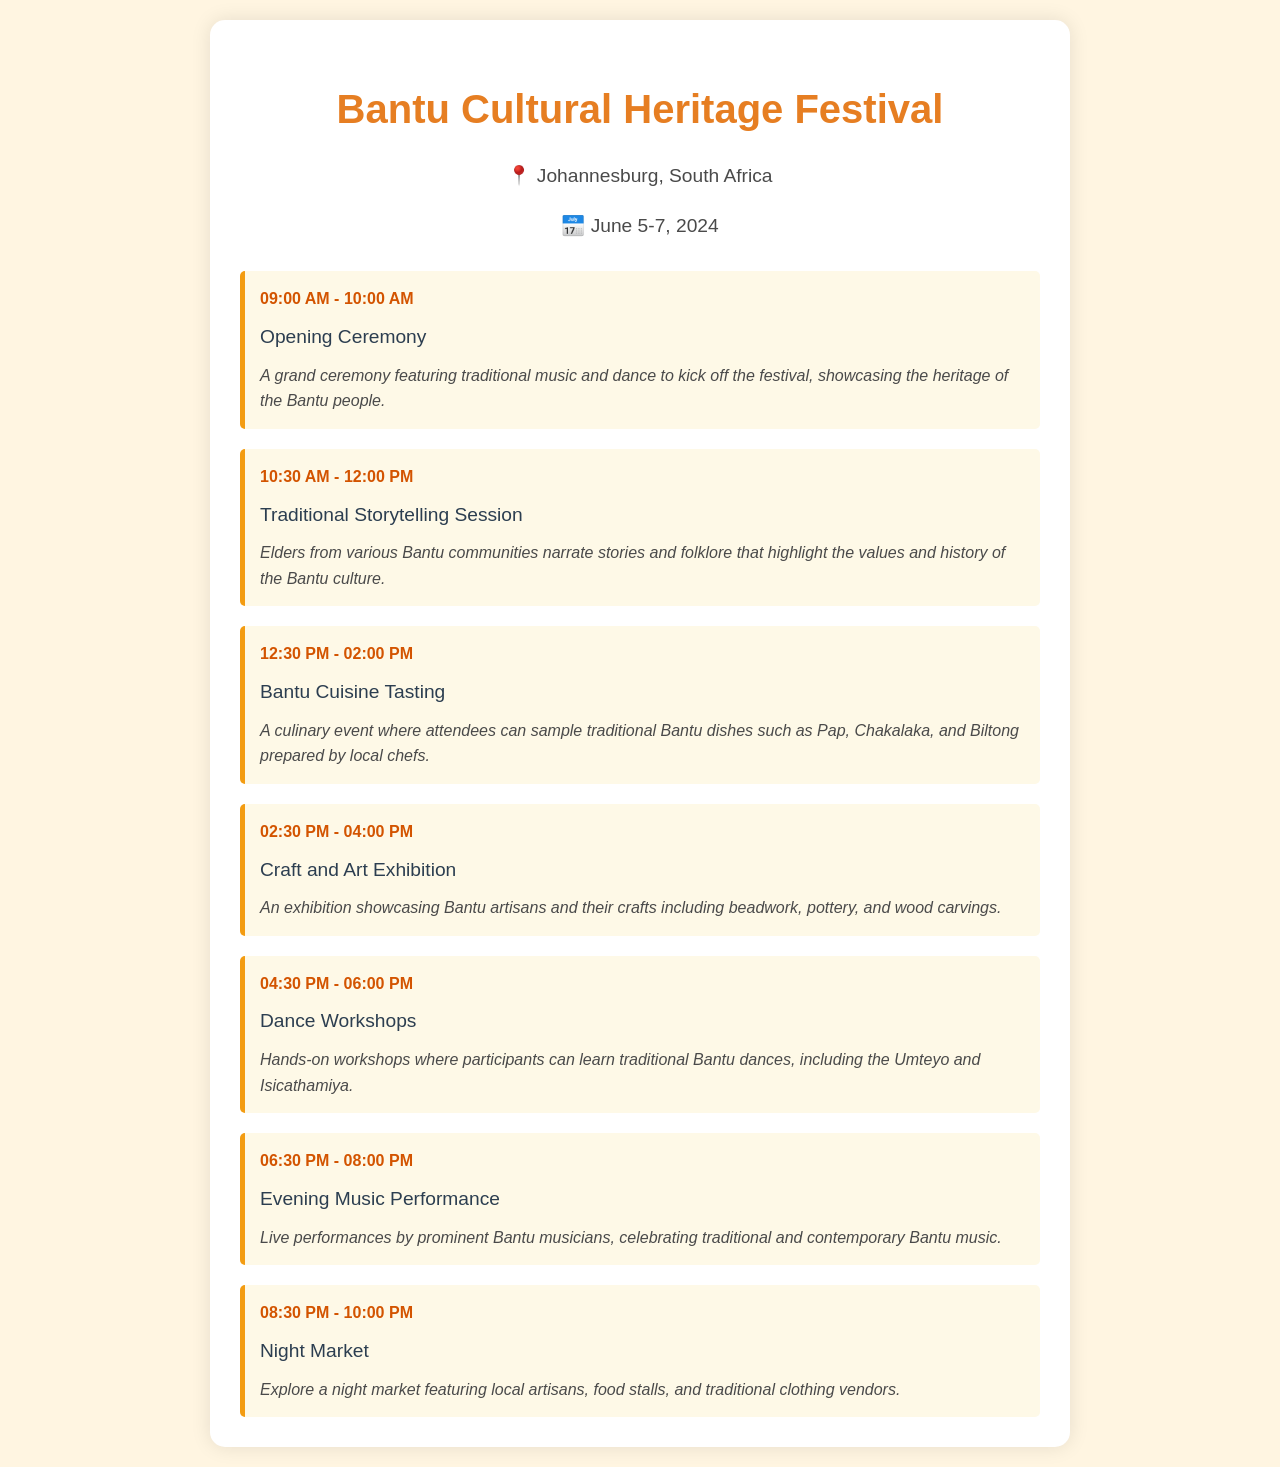What are the dates of the festival? The document states that the festival runs from June 5 to June 7, 2024.
Answer: June 5-7, 2024 What is the location of the festival? The festival takes place in Johannesburg, South Africa.
Answer: Johannesburg, South Africa What event starts at 04:30 PM? The event scheduled for 04:30 PM is the Dance Workshops.
Answer: Dance Workshops How long is the Traditional Storytelling Session? The session is scheduled from 10:30 AM to 12:00 PM, lasting 1 hour and 30 minutes.
Answer: 1 hour 30 minutes Which traditional dish is mentioned in the Bantu Cuisine Tasting? The document lists Pap as one of the traditional dishes provided during the tasting event.
Answer: Pap What can attendees learn in the Dance Workshops? Attendees can learn traditional Bantu dances.
Answer: Traditional Bantu dances What type of performance is scheduled for the evening? The schedule includes a music performance featuring Bantu musicians in the evening.
Answer: Evening Music Performance What is the last event of the day? The last event listed is the Night Market.
Answer: Night Market 